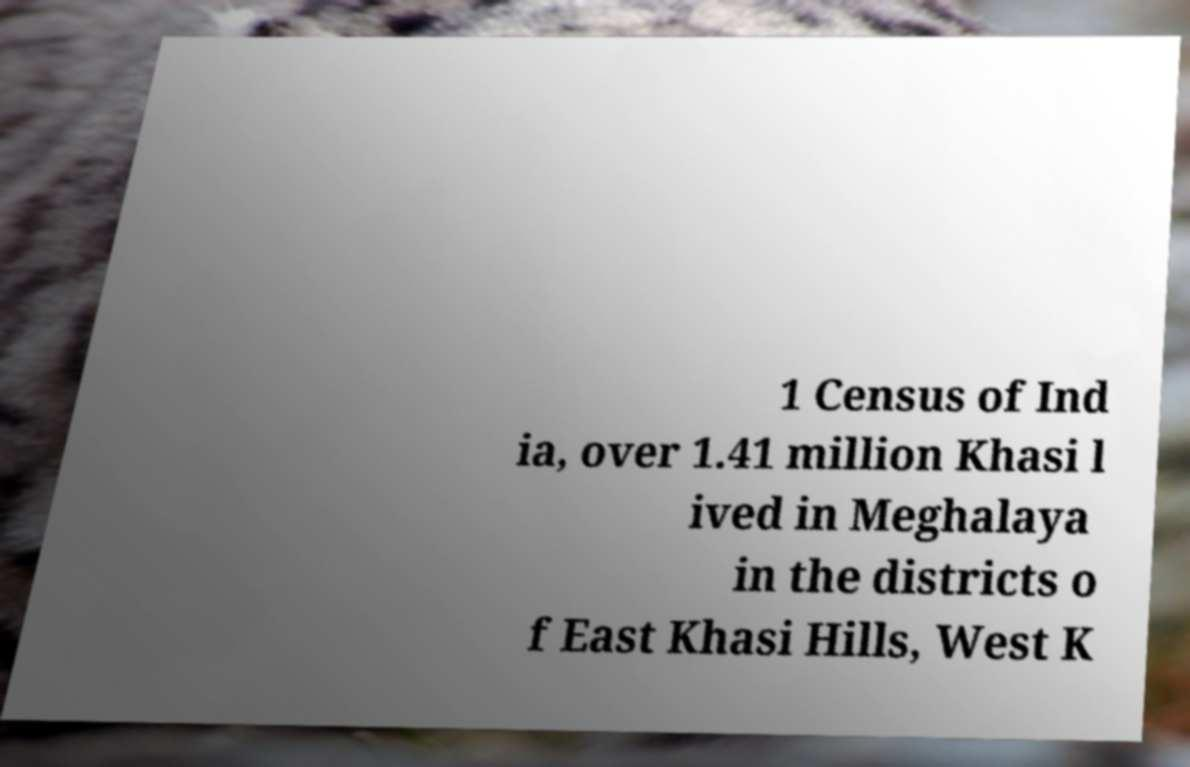There's text embedded in this image that I need extracted. Can you transcribe it verbatim? 1 Census of Ind ia, over 1.41 million Khasi l ived in Meghalaya in the districts o f East Khasi Hills, West K 